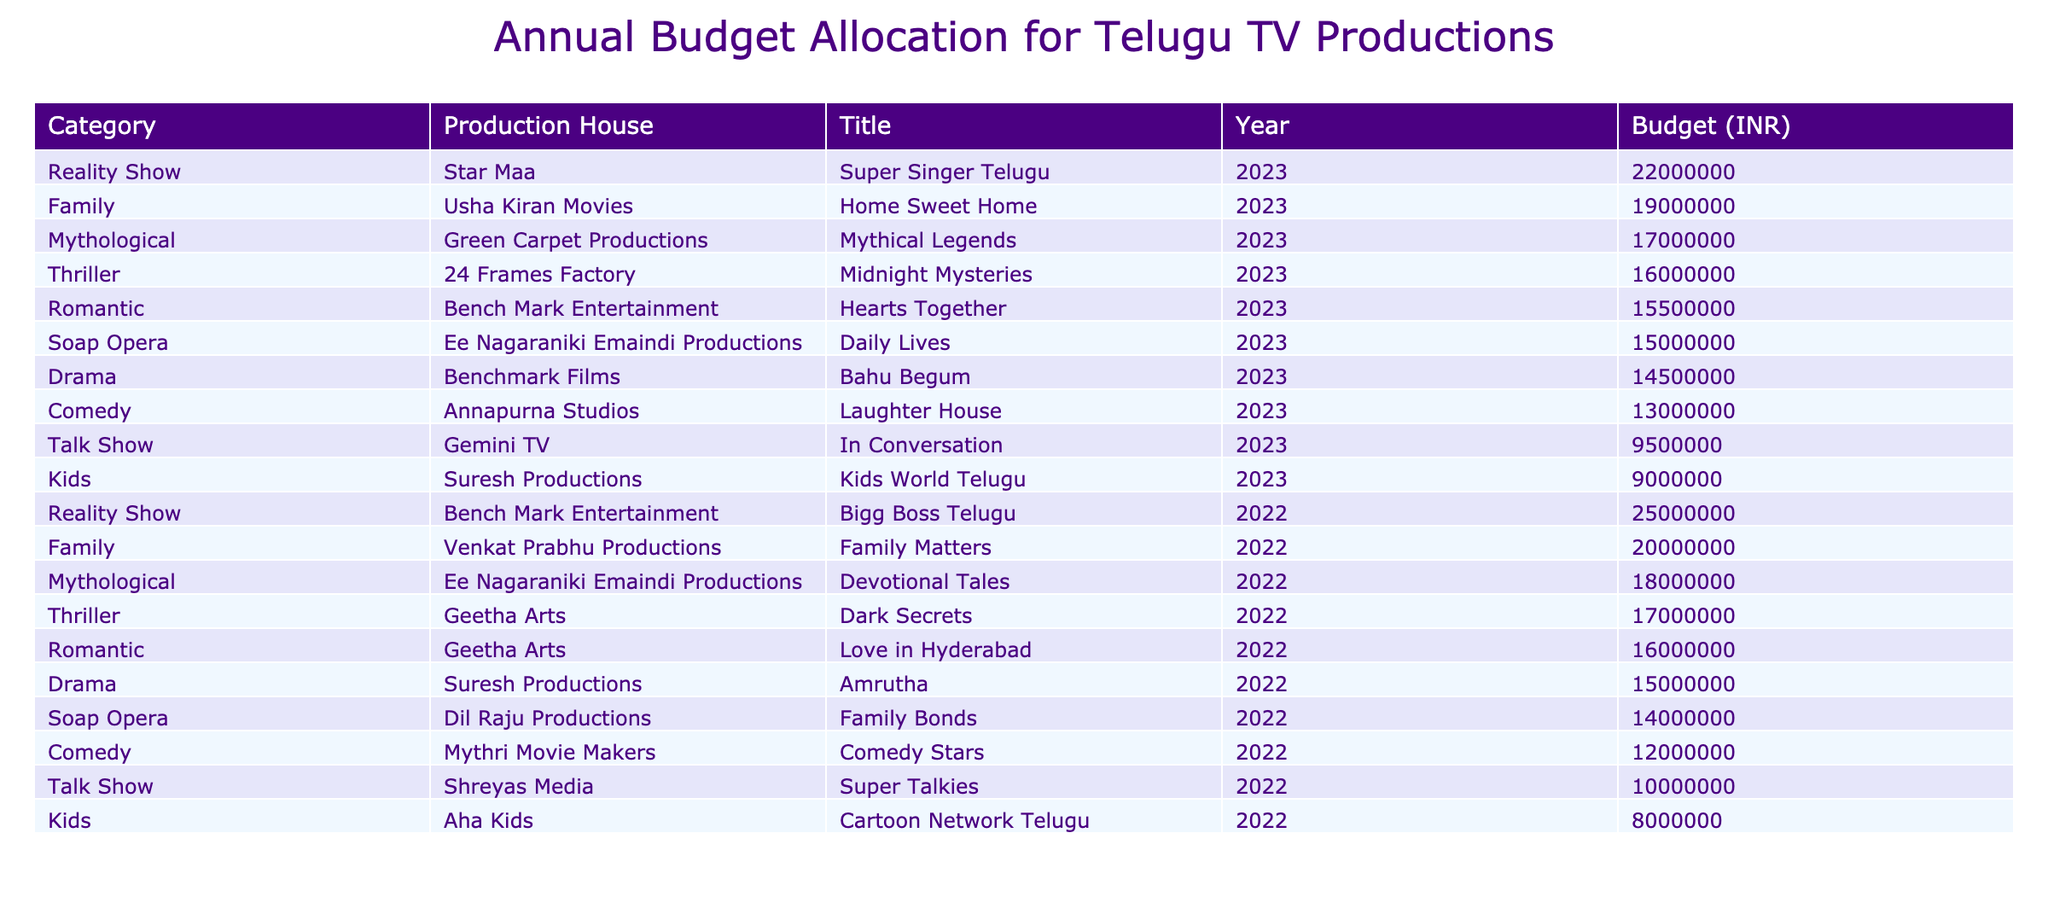What is the highest budget allocated for a single production? The highest budget can be found by looking at the 'Budget (INR)' column. The highest value is 25,000,000 for the production "Bigg Boss Telugu" by Bench Mark Entertainment in 2022.
Answer: 25000000 Which production received the lowest budget? By inspecting the 'Budget (INR)' column, we see "Kids World Telugu" by Suresh Productions, which received a budget of 9,000,000 in 2023. This is the lowest value among all productions listed.
Answer: 9000000 How much total budget was allocated to Reality Shows in 2022 and 2023 combined? To find the total budget for Reality Shows, we need to sum the budgets of both years. For 2022, "Bigg Boss Telugu" received 25,000,000, and for 2023, "Super Singer Telugu" received 22,000,000. Thus, 25,000,000 + 22,000,000 = 47,000,000 in total.
Answer: 47000000 Was the budget for "Home Sweet Home" more than the budget for "Daily Lives"? We can check the budget for both productions; "Home Sweet Home" received 19,000,000 and "Daily Lives" received 15,000,000. Since 19,000,000 is greater than 15,000,000, the statement is true.
Answer: Yes What is the average budget allocated to Mythological productions across both years? For Mythological productions, we have "Devotional Tales" (18,000,000) and "Mythical Legends" (17,000,000). To find the average, we sum these values: 18,000,000 + 17,000,000 = 35,000,000 and then divide by 2, resulting in an average of 17,500,000.
Answer: 17500000 What category had the highest total budget across all productions? To determine the category with the highest total budget, we sum the budgets for each category: Drama (15,000,000 + 14,500,000), Reality Show (25,000,000 + 22,000,000), Comedy (12,000,000 + 13,000,000), etc. The Reality Show category totals to 47,000,000, which is the highest among all categories calculated.
Answer: Reality Show How many productions had a budget of over 16,000,000 in 2022? By checking the budgets for the year 2022, we find four productions with budgets over 16,000,000: "Bigg Boss Telugu" (25,000,000), "Family Matters" (20,000,000), "Dark Secrets" (17,000,000), and "Devotional Tales" (18,000,000). Therefore, the count is 4.
Answer: 4 Did any production house have productions in both years listed? Looking through the table, "Geetha Arts" produced "Dark Secrets" in 2022 and "Love in Hyderabad" in 2022, which confirms that they had productions in both years.
Answer: Yes 